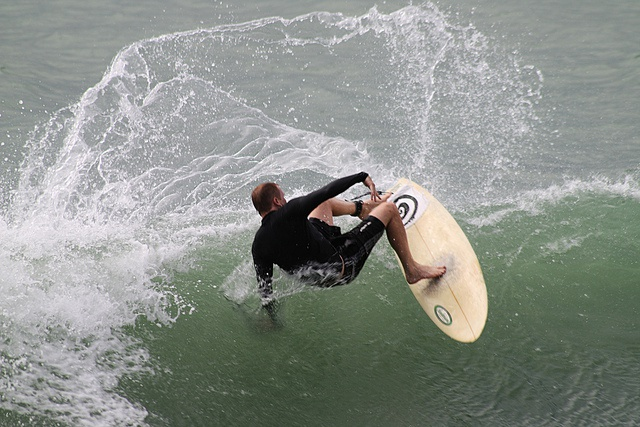Describe the objects in this image and their specific colors. I can see people in gray, black, darkgray, and brown tones and surfboard in gray, lightgray, and tan tones in this image. 